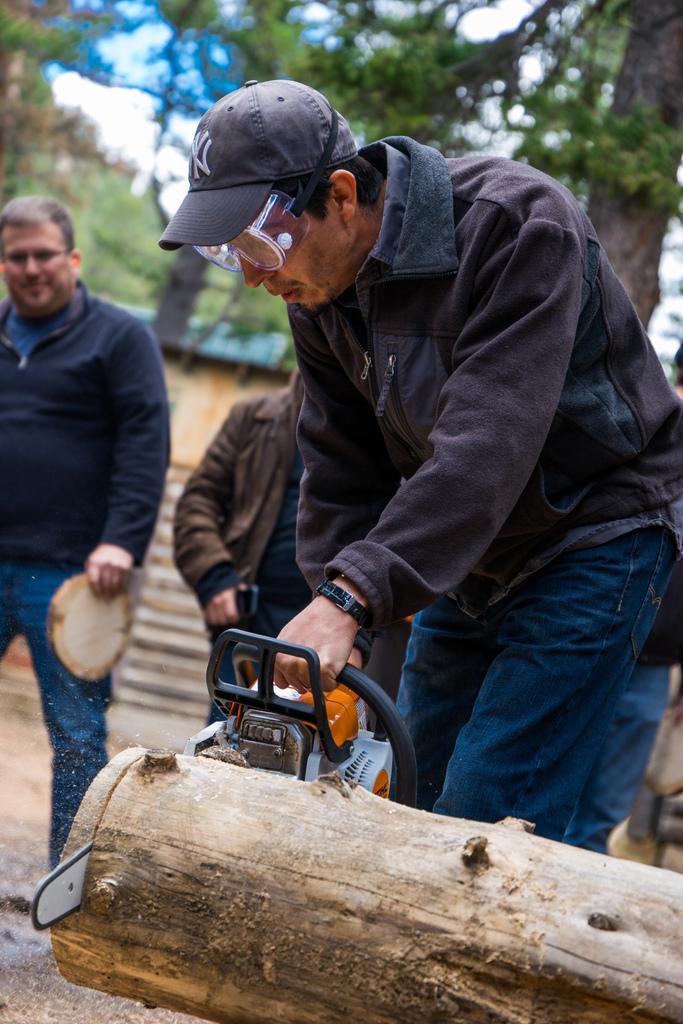Can you describe this image briefly? In this picture we can see a man wearing black jacket is cutting the tree trunk with the machine. Behind there is a person standing and looking to him. In the background there are some trees. 